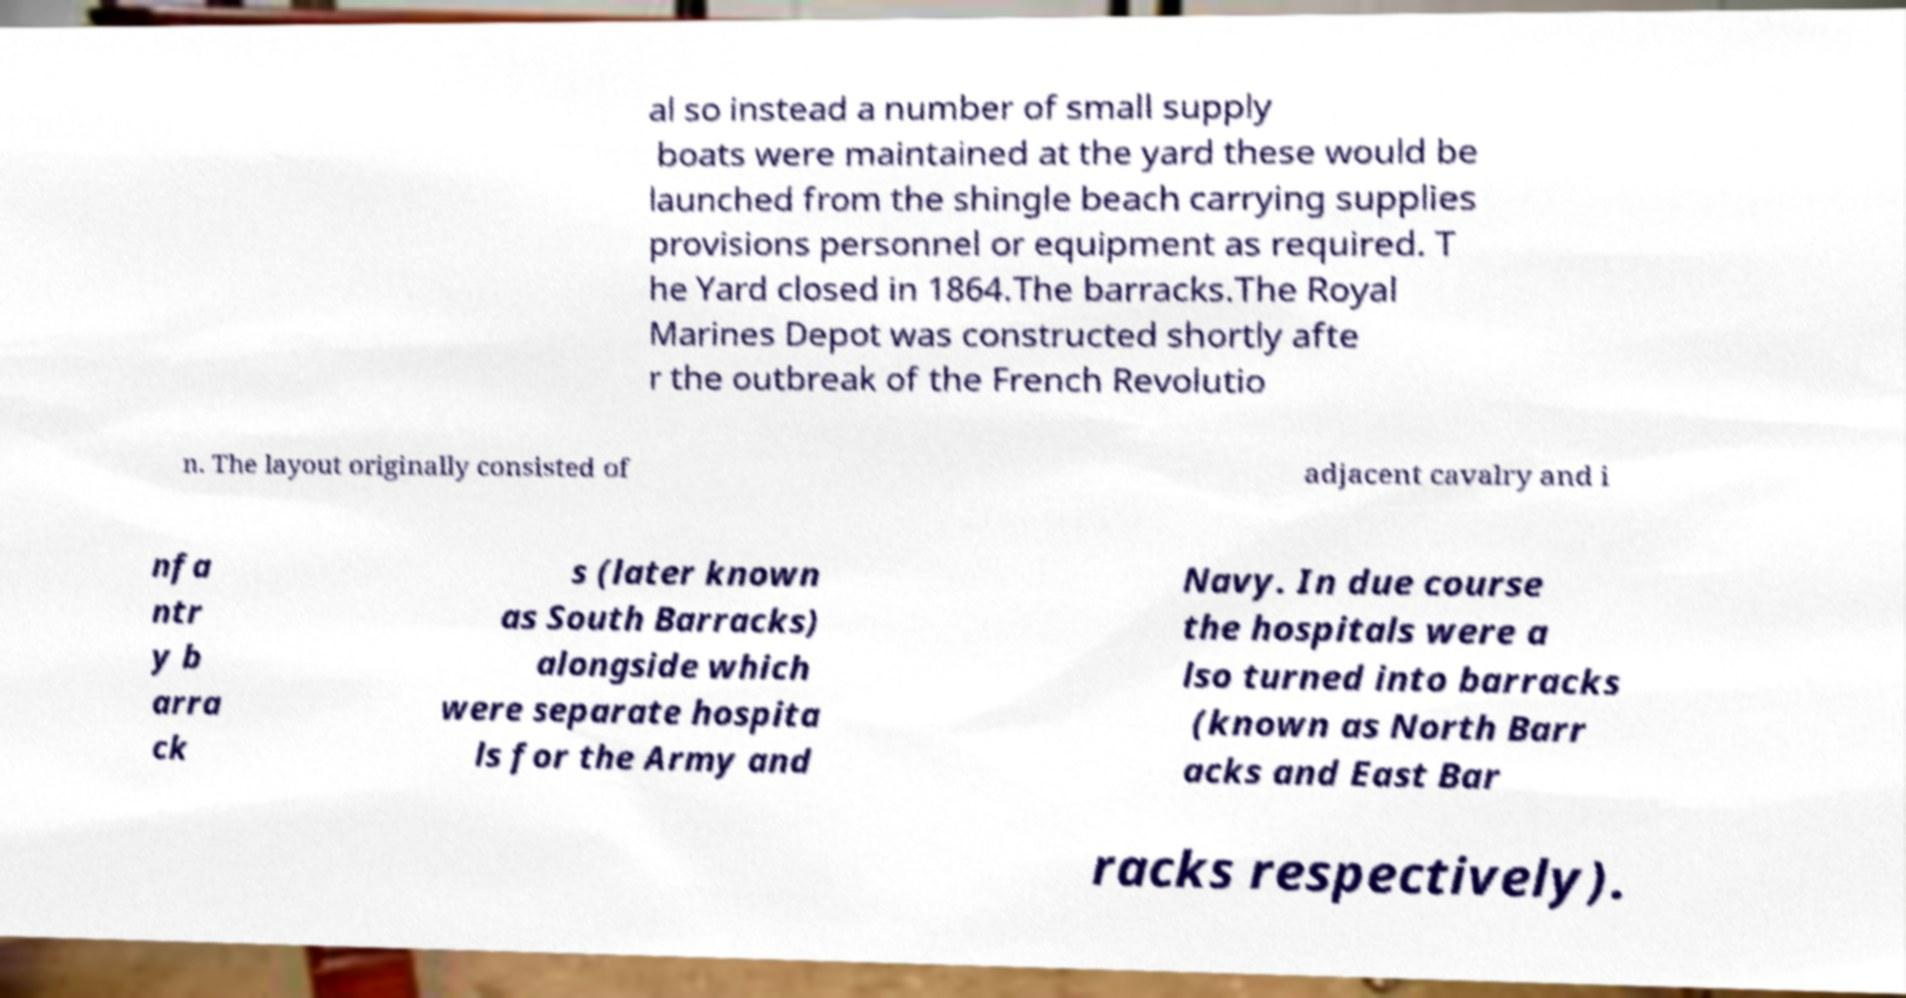For documentation purposes, I need the text within this image transcribed. Could you provide that? al so instead a number of small supply boats were maintained at the yard these would be launched from the shingle beach carrying supplies provisions personnel or equipment as required. T he Yard closed in 1864.The barracks.The Royal Marines Depot was constructed shortly afte r the outbreak of the French Revolutio n. The layout originally consisted of adjacent cavalry and i nfa ntr y b arra ck s (later known as South Barracks) alongside which were separate hospita ls for the Army and Navy. In due course the hospitals were a lso turned into barracks (known as North Barr acks and East Bar racks respectively). 